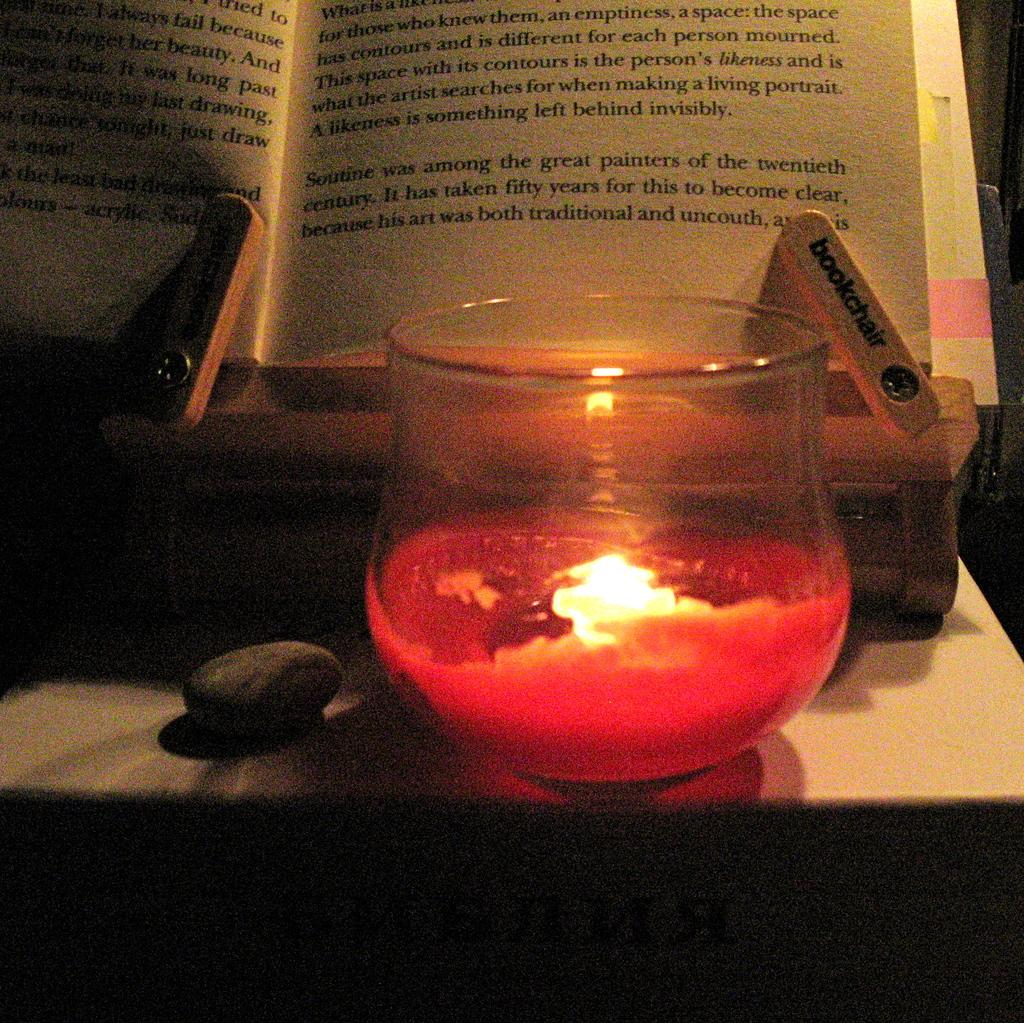What is the main piece of furniture in the image? There is a table in the image. What items can be seen on the table? There are books, candles, glasses, and a stone on the table. Is there any text visible in the image? Yes, there is text visible on the table. What might be used for lighting in the image? Candles can be used for lighting in the image. What type of sleet can be seen falling on the table in the image? There is no sleet present in the image; it is a dry scene with no precipitation. Where is the shelf located in the image? There is no shelf present in the image; the conversation focuses on the items on the table. 